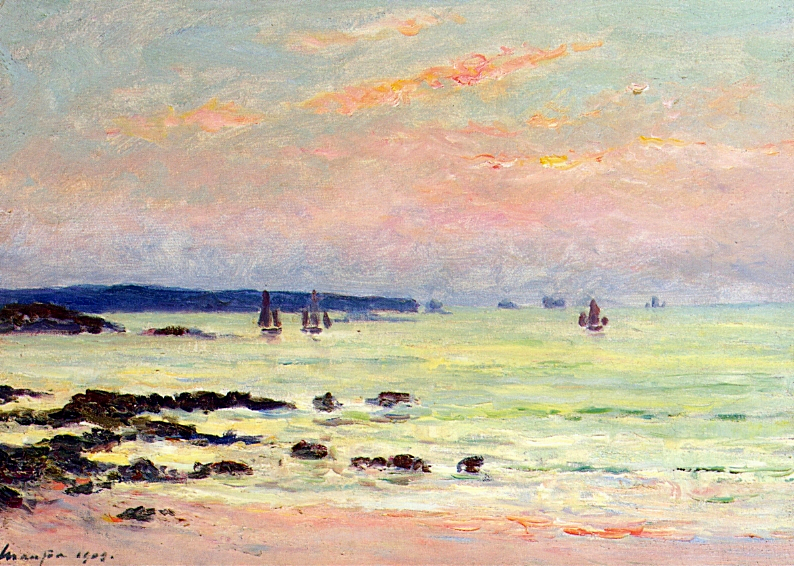Could you explain the significance of the color palette used in this painting? Absolutely, the color palette Monet chose is fundamental in conveying the atmosphere of the seascape. The use of light blue and pink hues in the sky suggests a serene, early morning or late afternoon setting, where the sun's rays gently color the clouds. The greens and blues of the sea reflect the natural variations in the water's depth and the influence of light, enhancing the painting's dynamism and realism. This choice of colors is also indicative of Monet's style, which often employs vibrant yet harmonious colors to capture fleeting moments in time. 